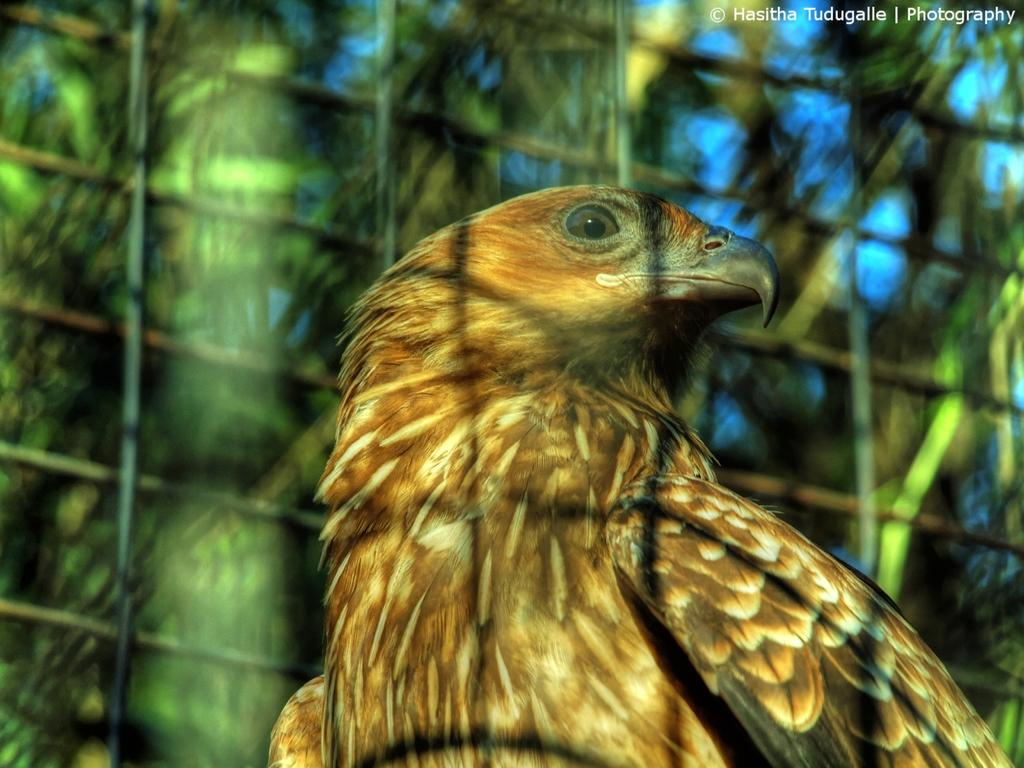What type of animal can be seen in the image? There is a bird in the image. What is the bird situated in or near? There is a mesh in the image. Can you describe the background of the image? The background of the image is blurred. Is there any text or logo visible in the image? Yes, there is a watermark in the top right corner of the image. What is the bird arguing with the porter about in the image? There is no argument or porter present in the image; it only features a bird and a mesh. 